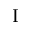<formula> <loc_0><loc_0><loc_500><loc_500>I</formula> 